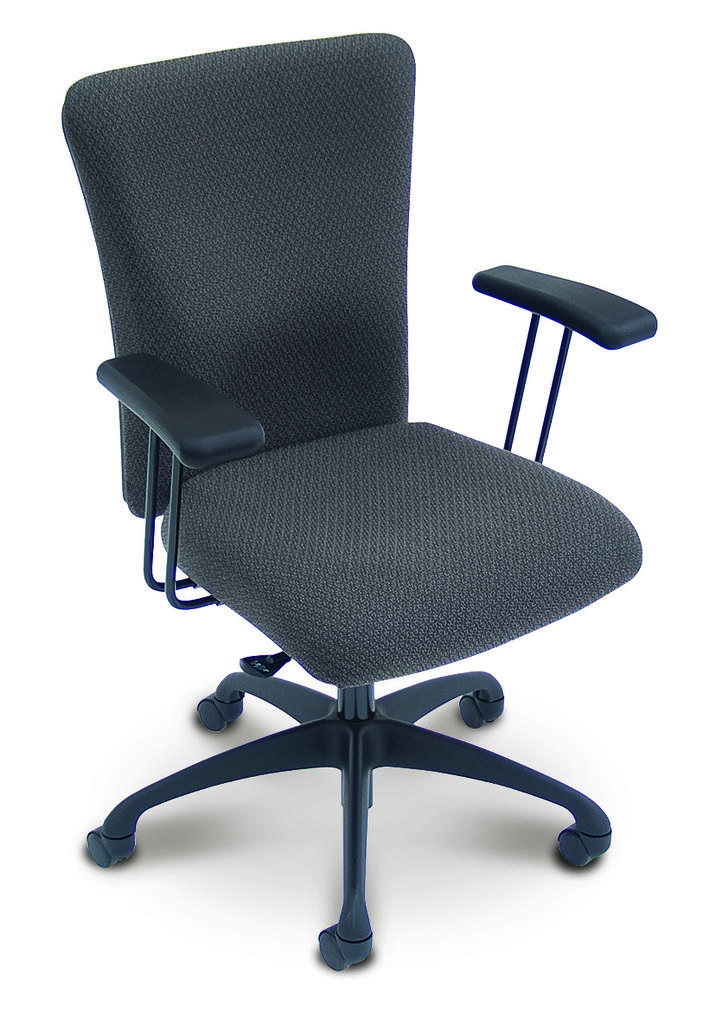What type of furniture is in the picture? There is a chair in the picture. What are the notable features of the chair? The chair has wheels and armrests. What is the color of the chair? The chair is black in color. What is the chair placed on? The chair is placed on a white surface. Can you describe the argument between the chair and the table in the image? There is no argument between the chair and the table in the image, as furniture does not engage in arguments. 